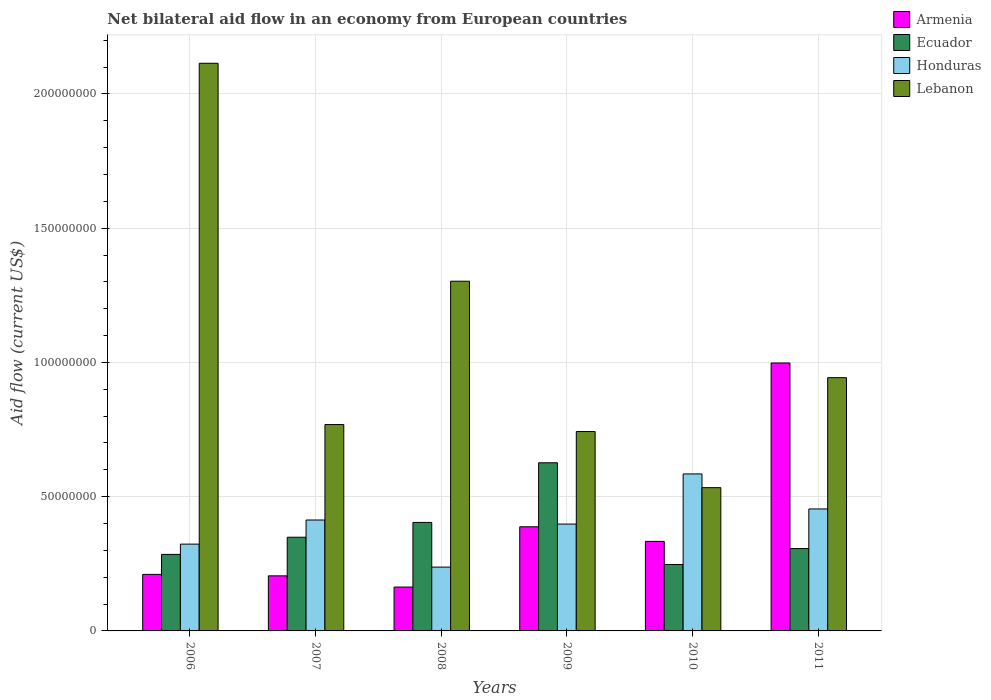How many different coloured bars are there?
Provide a succinct answer. 4. Are the number of bars on each tick of the X-axis equal?
Ensure brevity in your answer.  Yes. How many bars are there on the 2nd tick from the left?
Ensure brevity in your answer.  4. What is the net bilateral aid flow in Lebanon in 2011?
Provide a short and direct response. 9.43e+07. Across all years, what is the maximum net bilateral aid flow in Ecuador?
Keep it short and to the point. 6.26e+07. Across all years, what is the minimum net bilateral aid flow in Ecuador?
Your answer should be compact. 2.47e+07. In which year was the net bilateral aid flow in Armenia minimum?
Ensure brevity in your answer.  2008. What is the total net bilateral aid flow in Honduras in the graph?
Keep it short and to the point. 2.41e+08. What is the difference between the net bilateral aid flow in Honduras in 2008 and that in 2011?
Keep it short and to the point. -2.17e+07. What is the difference between the net bilateral aid flow in Armenia in 2007 and the net bilateral aid flow in Ecuador in 2009?
Ensure brevity in your answer.  -4.21e+07. What is the average net bilateral aid flow in Honduras per year?
Provide a short and direct response. 4.02e+07. In the year 2007, what is the difference between the net bilateral aid flow in Lebanon and net bilateral aid flow in Armenia?
Give a very brief answer. 5.64e+07. In how many years, is the net bilateral aid flow in Armenia greater than 90000000 US$?
Provide a short and direct response. 1. What is the ratio of the net bilateral aid flow in Ecuador in 2009 to that in 2011?
Keep it short and to the point. 2.04. Is the net bilateral aid flow in Honduras in 2010 less than that in 2011?
Your response must be concise. No. Is the difference between the net bilateral aid flow in Lebanon in 2006 and 2008 greater than the difference between the net bilateral aid flow in Armenia in 2006 and 2008?
Your answer should be very brief. Yes. What is the difference between the highest and the second highest net bilateral aid flow in Ecuador?
Give a very brief answer. 2.22e+07. What is the difference between the highest and the lowest net bilateral aid flow in Ecuador?
Offer a terse response. 3.79e+07. What does the 4th bar from the left in 2007 represents?
Keep it short and to the point. Lebanon. What does the 3rd bar from the right in 2006 represents?
Your response must be concise. Ecuador. Is it the case that in every year, the sum of the net bilateral aid flow in Lebanon and net bilateral aid flow in Armenia is greater than the net bilateral aid flow in Honduras?
Give a very brief answer. Yes. Are all the bars in the graph horizontal?
Provide a succinct answer. No. How many years are there in the graph?
Provide a short and direct response. 6. What is the difference between two consecutive major ticks on the Y-axis?
Offer a very short reply. 5.00e+07. Does the graph contain any zero values?
Offer a terse response. No. Does the graph contain grids?
Provide a short and direct response. Yes. Where does the legend appear in the graph?
Offer a very short reply. Top right. What is the title of the graph?
Keep it short and to the point. Net bilateral aid flow in an economy from European countries. What is the label or title of the X-axis?
Offer a very short reply. Years. What is the Aid flow (current US$) of Armenia in 2006?
Provide a succinct answer. 2.10e+07. What is the Aid flow (current US$) in Ecuador in 2006?
Ensure brevity in your answer.  2.85e+07. What is the Aid flow (current US$) of Honduras in 2006?
Offer a very short reply. 3.23e+07. What is the Aid flow (current US$) in Lebanon in 2006?
Ensure brevity in your answer.  2.11e+08. What is the Aid flow (current US$) of Armenia in 2007?
Your answer should be very brief. 2.05e+07. What is the Aid flow (current US$) in Ecuador in 2007?
Offer a very short reply. 3.49e+07. What is the Aid flow (current US$) in Honduras in 2007?
Provide a succinct answer. 4.13e+07. What is the Aid flow (current US$) in Lebanon in 2007?
Give a very brief answer. 7.69e+07. What is the Aid flow (current US$) of Armenia in 2008?
Your answer should be very brief. 1.63e+07. What is the Aid flow (current US$) in Ecuador in 2008?
Make the answer very short. 4.04e+07. What is the Aid flow (current US$) of Honduras in 2008?
Offer a very short reply. 2.38e+07. What is the Aid flow (current US$) of Lebanon in 2008?
Provide a short and direct response. 1.30e+08. What is the Aid flow (current US$) in Armenia in 2009?
Give a very brief answer. 3.88e+07. What is the Aid flow (current US$) in Ecuador in 2009?
Give a very brief answer. 6.26e+07. What is the Aid flow (current US$) of Honduras in 2009?
Give a very brief answer. 3.98e+07. What is the Aid flow (current US$) of Lebanon in 2009?
Your answer should be compact. 7.43e+07. What is the Aid flow (current US$) of Armenia in 2010?
Your response must be concise. 3.34e+07. What is the Aid flow (current US$) in Ecuador in 2010?
Keep it short and to the point. 2.47e+07. What is the Aid flow (current US$) of Honduras in 2010?
Give a very brief answer. 5.85e+07. What is the Aid flow (current US$) in Lebanon in 2010?
Give a very brief answer. 5.34e+07. What is the Aid flow (current US$) in Armenia in 2011?
Provide a succinct answer. 9.98e+07. What is the Aid flow (current US$) in Ecuador in 2011?
Keep it short and to the point. 3.07e+07. What is the Aid flow (current US$) in Honduras in 2011?
Your answer should be compact. 4.54e+07. What is the Aid flow (current US$) of Lebanon in 2011?
Keep it short and to the point. 9.43e+07. Across all years, what is the maximum Aid flow (current US$) of Armenia?
Provide a short and direct response. 9.98e+07. Across all years, what is the maximum Aid flow (current US$) in Ecuador?
Your answer should be very brief. 6.26e+07. Across all years, what is the maximum Aid flow (current US$) in Honduras?
Provide a succinct answer. 5.85e+07. Across all years, what is the maximum Aid flow (current US$) in Lebanon?
Your answer should be compact. 2.11e+08. Across all years, what is the minimum Aid flow (current US$) of Armenia?
Your answer should be very brief. 1.63e+07. Across all years, what is the minimum Aid flow (current US$) in Ecuador?
Offer a terse response. 2.47e+07. Across all years, what is the minimum Aid flow (current US$) in Honduras?
Provide a succinct answer. 2.38e+07. Across all years, what is the minimum Aid flow (current US$) of Lebanon?
Your answer should be very brief. 5.34e+07. What is the total Aid flow (current US$) of Armenia in the graph?
Keep it short and to the point. 2.30e+08. What is the total Aid flow (current US$) in Ecuador in the graph?
Your response must be concise. 2.22e+08. What is the total Aid flow (current US$) in Honduras in the graph?
Give a very brief answer. 2.41e+08. What is the total Aid flow (current US$) in Lebanon in the graph?
Ensure brevity in your answer.  6.40e+08. What is the difference between the Aid flow (current US$) of Armenia in 2006 and that in 2007?
Your answer should be very brief. 5.40e+05. What is the difference between the Aid flow (current US$) of Ecuador in 2006 and that in 2007?
Keep it short and to the point. -6.40e+06. What is the difference between the Aid flow (current US$) of Honduras in 2006 and that in 2007?
Offer a terse response. -8.98e+06. What is the difference between the Aid flow (current US$) in Lebanon in 2006 and that in 2007?
Offer a very short reply. 1.35e+08. What is the difference between the Aid flow (current US$) in Armenia in 2006 and that in 2008?
Ensure brevity in your answer.  4.71e+06. What is the difference between the Aid flow (current US$) of Ecuador in 2006 and that in 2008?
Ensure brevity in your answer.  -1.19e+07. What is the difference between the Aid flow (current US$) of Honduras in 2006 and that in 2008?
Your answer should be very brief. 8.56e+06. What is the difference between the Aid flow (current US$) of Lebanon in 2006 and that in 2008?
Your answer should be very brief. 8.12e+07. What is the difference between the Aid flow (current US$) in Armenia in 2006 and that in 2009?
Your response must be concise. -1.77e+07. What is the difference between the Aid flow (current US$) in Ecuador in 2006 and that in 2009?
Make the answer very short. -3.41e+07. What is the difference between the Aid flow (current US$) in Honduras in 2006 and that in 2009?
Your answer should be very brief. -7.47e+06. What is the difference between the Aid flow (current US$) of Lebanon in 2006 and that in 2009?
Your answer should be very brief. 1.37e+08. What is the difference between the Aid flow (current US$) of Armenia in 2006 and that in 2010?
Your answer should be compact. -1.23e+07. What is the difference between the Aid flow (current US$) of Ecuador in 2006 and that in 2010?
Provide a short and direct response. 3.76e+06. What is the difference between the Aid flow (current US$) in Honduras in 2006 and that in 2010?
Your answer should be very brief. -2.61e+07. What is the difference between the Aid flow (current US$) of Lebanon in 2006 and that in 2010?
Give a very brief answer. 1.58e+08. What is the difference between the Aid flow (current US$) in Armenia in 2006 and that in 2011?
Keep it short and to the point. -7.87e+07. What is the difference between the Aid flow (current US$) in Ecuador in 2006 and that in 2011?
Give a very brief answer. -2.18e+06. What is the difference between the Aid flow (current US$) in Honduras in 2006 and that in 2011?
Give a very brief answer. -1.31e+07. What is the difference between the Aid flow (current US$) of Lebanon in 2006 and that in 2011?
Give a very brief answer. 1.17e+08. What is the difference between the Aid flow (current US$) of Armenia in 2007 and that in 2008?
Offer a very short reply. 4.17e+06. What is the difference between the Aid flow (current US$) in Ecuador in 2007 and that in 2008?
Your answer should be compact. -5.51e+06. What is the difference between the Aid flow (current US$) of Honduras in 2007 and that in 2008?
Keep it short and to the point. 1.75e+07. What is the difference between the Aid flow (current US$) of Lebanon in 2007 and that in 2008?
Make the answer very short. -5.34e+07. What is the difference between the Aid flow (current US$) of Armenia in 2007 and that in 2009?
Provide a succinct answer. -1.83e+07. What is the difference between the Aid flow (current US$) of Ecuador in 2007 and that in 2009?
Make the answer very short. -2.77e+07. What is the difference between the Aid flow (current US$) in Honduras in 2007 and that in 2009?
Provide a short and direct response. 1.51e+06. What is the difference between the Aid flow (current US$) of Lebanon in 2007 and that in 2009?
Offer a very short reply. 2.60e+06. What is the difference between the Aid flow (current US$) of Armenia in 2007 and that in 2010?
Keep it short and to the point. -1.28e+07. What is the difference between the Aid flow (current US$) in Ecuador in 2007 and that in 2010?
Give a very brief answer. 1.02e+07. What is the difference between the Aid flow (current US$) of Honduras in 2007 and that in 2010?
Your answer should be compact. -1.72e+07. What is the difference between the Aid flow (current US$) in Lebanon in 2007 and that in 2010?
Offer a very short reply. 2.35e+07. What is the difference between the Aid flow (current US$) in Armenia in 2007 and that in 2011?
Make the answer very short. -7.93e+07. What is the difference between the Aid flow (current US$) of Ecuador in 2007 and that in 2011?
Your response must be concise. 4.22e+06. What is the difference between the Aid flow (current US$) in Honduras in 2007 and that in 2011?
Make the answer very short. -4.12e+06. What is the difference between the Aid flow (current US$) of Lebanon in 2007 and that in 2011?
Keep it short and to the point. -1.75e+07. What is the difference between the Aid flow (current US$) in Armenia in 2008 and that in 2009?
Your answer should be very brief. -2.24e+07. What is the difference between the Aid flow (current US$) in Ecuador in 2008 and that in 2009?
Make the answer very short. -2.22e+07. What is the difference between the Aid flow (current US$) in Honduras in 2008 and that in 2009?
Keep it short and to the point. -1.60e+07. What is the difference between the Aid flow (current US$) of Lebanon in 2008 and that in 2009?
Give a very brief answer. 5.60e+07. What is the difference between the Aid flow (current US$) of Armenia in 2008 and that in 2010?
Make the answer very short. -1.70e+07. What is the difference between the Aid flow (current US$) in Ecuador in 2008 and that in 2010?
Give a very brief answer. 1.57e+07. What is the difference between the Aid flow (current US$) of Honduras in 2008 and that in 2010?
Give a very brief answer. -3.47e+07. What is the difference between the Aid flow (current US$) of Lebanon in 2008 and that in 2010?
Your response must be concise. 7.69e+07. What is the difference between the Aid flow (current US$) in Armenia in 2008 and that in 2011?
Offer a very short reply. -8.34e+07. What is the difference between the Aid flow (current US$) in Ecuador in 2008 and that in 2011?
Your answer should be compact. 9.73e+06. What is the difference between the Aid flow (current US$) of Honduras in 2008 and that in 2011?
Your response must be concise. -2.17e+07. What is the difference between the Aid flow (current US$) in Lebanon in 2008 and that in 2011?
Make the answer very short. 3.59e+07. What is the difference between the Aid flow (current US$) in Armenia in 2009 and that in 2010?
Keep it short and to the point. 5.44e+06. What is the difference between the Aid flow (current US$) of Ecuador in 2009 and that in 2010?
Offer a terse response. 3.79e+07. What is the difference between the Aid flow (current US$) of Honduras in 2009 and that in 2010?
Provide a succinct answer. -1.87e+07. What is the difference between the Aid flow (current US$) in Lebanon in 2009 and that in 2010?
Offer a terse response. 2.09e+07. What is the difference between the Aid flow (current US$) of Armenia in 2009 and that in 2011?
Your response must be concise. -6.10e+07. What is the difference between the Aid flow (current US$) in Ecuador in 2009 and that in 2011?
Offer a very short reply. 3.20e+07. What is the difference between the Aid flow (current US$) in Honduras in 2009 and that in 2011?
Your answer should be compact. -5.63e+06. What is the difference between the Aid flow (current US$) of Lebanon in 2009 and that in 2011?
Give a very brief answer. -2.01e+07. What is the difference between the Aid flow (current US$) of Armenia in 2010 and that in 2011?
Your answer should be compact. -6.64e+07. What is the difference between the Aid flow (current US$) of Ecuador in 2010 and that in 2011?
Make the answer very short. -5.94e+06. What is the difference between the Aid flow (current US$) of Honduras in 2010 and that in 2011?
Keep it short and to the point. 1.30e+07. What is the difference between the Aid flow (current US$) in Lebanon in 2010 and that in 2011?
Ensure brevity in your answer.  -4.10e+07. What is the difference between the Aid flow (current US$) in Armenia in 2006 and the Aid flow (current US$) in Ecuador in 2007?
Make the answer very short. -1.38e+07. What is the difference between the Aid flow (current US$) in Armenia in 2006 and the Aid flow (current US$) in Honduras in 2007?
Your answer should be very brief. -2.03e+07. What is the difference between the Aid flow (current US$) in Armenia in 2006 and the Aid flow (current US$) in Lebanon in 2007?
Make the answer very short. -5.58e+07. What is the difference between the Aid flow (current US$) in Ecuador in 2006 and the Aid flow (current US$) in Honduras in 2007?
Make the answer very short. -1.28e+07. What is the difference between the Aid flow (current US$) in Ecuador in 2006 and the Aid flow (current US$) in Lebanon in 2007?
Keep it short and to the point. -4.84e+07. What is the difference between the Aid flow (current US$) of Honduras in 2006 and the Aid flow (current US$) of Lebanon in 2007?
Ensure brevity in your answer.  -4.45e+07. What is the difference between the Aid flow (current US$) in Armenia in 2006 and the Aid flow (current US$) in Ecuador in 2008?
Your answer should be compact. -1.94e+07. What is the difference between the Aid flow (current US$) in Armenia in 2006 and the Aid flow (current US$) in Honduras in 2008?
Your answer should be compact. -2.72e+06. What is the difference between the Aid flow (current US$) of Armenia in 2006 and the Aid flow (current US$) of Lebanon in 2008?
Your answer should be compact. -1.09e+08. What is the difference between the Aid flow (current US$) in Ecuador in 2006 and the Aid flow (current US$) in Honduras in 2008?
Give a very brief answer. 4.73e+06. What is the difference between the Aid flow (current US$) of Ecuador in 2006 and the Aid flow (current US$) of Lebanon in 2008?
Offer a terse response. -1.02e+08. What is the difference between the Aid flow (current US$) in Honduras in 2006 and the Aid flow (current US$) in Lebanon in 2008?
Your answer should be compact. -9.79e+07. What is the difference between the Aid flow (current US$) in Armenia in 2006 and the Aid flow (current US$) in Ecuador in 2009?
Your answer should be very brief. -4.16e+07. What is the difference between the Aid flow (current US$) in Armenia in 2006 and the Aid flow (current US$) in Honduras in 2009?
Ensure brevity in your answer.  -1.88e+07. What is the difference between the Aid flow (current US$) of Armenia in 2006 and the Aid flow (current US$) of Lebanon in 2009?
Your answer should be compact. -5.32e+07. What is the difference between the Aid flow (current US$) in Ecuador in 2006 and the Aid flow (current US$) in Honduras in 2009?
Provide a short and direct response. -1.13e+07. What is the difference between the Aid flow (current US$) in Ecuador in 2006 and the Aid flow (current US$) in Lebanon in 2009?
Offer a terse response. -4.58e+07. What is the difference between the Aid flow (current US$) of Honduras in 2006 and the Aid flow (current US$) of Lebanon in 2009?
Provide a succinct answer. -4.19e+07. What is the difference between the Aid flow (current US$) in Armenia in 2006 and the Aid flow (current US$) in Ecuador in 2010?
Keep it short and to the point. -3.69e+06. What is the difference between the Aid flow (current US$) of Armenia in 2006 and the Aid flow (current US$) of Honduras in 2010?
Offer a terse response. -3.74e+07. What is the difference between the Aid flow (current US$) in Armenia in 2006 and the Aid flow (current US$) in Lebanon in 2010?
Your answer should be compact. -3.23e+07. What is the difference between the Aid flow (current US$) of Ecuador in 2006 and the Aid flow (current US$) of Honduras in 2010?
Your answer should be compact. -3.00e+07. What is the difference between the Aid flow (current US$) in Ecuador in 2006 and the Aid flow (current US$) in Lebanon in 2010?
Ensure brevity in your answer.  -2.49e+07. What is the difference between the Aid flow (current US$) in Honduras in 2006 and the Aid flow (current US$) in Lebanon in 2010?
Offer a terse response. -2.10e+07. What is the difference between the Aid flow (current US$) of Armenia in 2006 and the Aid flow (current US$) of Ecuador in 2011?
Your response must be concise. -9.63e+06. What is the difference between the Aid flow (current US$) of Armenia in 2006 and the Aid flow (current US$) of Honduras in 2011?
Your answer should be very brief. -2.44e+07. What is the difference between the Aid flow (current US$) in Armenia in 2006 and the Aid flow (current US$) in Lebanon in 2011?
Keep it short and to the point. -7.33e+07. What is the difference between the Aid flow (current US$) in Ecuador in 2006 and the Aid flow (current US$) in Honduras in 2011?
Provide a succinct answer. -1.69e+07. What is the difference between the Aid flow (current US$) in Ecuador in 2006 and the Aid flow (current US$) in Lebanon in 2011?
Provide a succinct answer. -6.58e+07. What is the difference between the Aid flow (current US$) of Honduras in 2006 and the Aid flow (current US$) of Lebanon in 2011?
Provide a short and direct response. -6.20e+07. What is the difference between the Aid flow (current US$) in Armenia in 2007 and the Aid flow (current US$) in Ecuador in 2008?
Offer a terse response. -1.99e+07. What is the difference between the Aid flow (current US$) of Armenia in 2007 and the Aid flow (current US$) of Honduras in 2008?
Give a very brief answer. -3.26e+06. What is the difference between the Aid flow (current US$) of Armenia in 2007 and the Aid flow (current US$) of Lebanon in 2008?
Provide a succinct answer. -1.10e+08. What is the difference between the Aid flow (current US$) in Ecuador in 2007 and the Aid flow (current US$) in Honduras in 2008?
Ensure brevity in your answer.  1.11e+07. What is the difference between the Aid flow (current US$) in Ecuador in 2007 and the Aid flow (current US$) in Lebanon in 2008?
Provide a short and direct response. -9.54e+07. What is the difference between the Aid flow (current US$) of Honduras in 2007 and the Aid flow (current US$) of Lebanon in 2008?
Offer a terse response. -8.89e+07. What is the difference between the Aid flow (current US$) of Armenia in 2007 and the Aid flow (current US$) of Ecuador in 2009?
Make the answer very short. -4.21e+07. What is the difference between the Aid flow (current US$) of Armenia in 2007 and the Aid flow (current US$) of Honduras in 2009?
Your response must be concise. -1.93e+07. What is the difference between the Aid flow (current US$) of Armenia in 2007 and the Aid flow (current US$) of Lebanon in 2009?
Ensure brevity in your answer.  -5.38e+07. What is the difference between the Aid flow (current US$) in Ecuador in 2007 and the Aid flow (current US$) in Honduras in 2009?
Provide a short and direct response. -4.90e+06. What is the difference between the Aid flow (current US$) in Ecuador in 2007 and the Aid flow (current US$) in Lebanon in 2009?
Ensure brevity in your answer.  -3.94e+07. What is the difference between the Aid flow (current US$) of Honduras in 2007 and the Aid flow (current US$) of Lebanon in 2009?
Give a very brief answer. -3.30e+07. What is the difference between the Aid flow (current US$) in Armenia in 2007 and the Aid flow (current US$) in Ecuador in 2010?
Offer a very short reply. -4.23e+06. What is the difference between the Aid flow (current US$) of Armenia in 2007 and the Aid flow (current US$) of Honduras in 2010?
Your answer should be compact. -3.80e+07. What is the difference between the Aid flow (current US$) in Armenia in 2007 and the Aid flow (current US$) in Lebanon in 2010?
Your answer should be compact. -3.28e+07. What is the difference between the Aid flow (current US$) of Ecuador in 2007 and the Aid flow (current US$) of Honduras in 2010?
Provide a short and direct response. -2.36e+07. What is the difference between the Aid flow (current US$) of Ecuador in 2007 and the Aid flow (current US$) of Lebanon in 2010?
Offer a terse response. -1.85e+07. What is the difference between the Aid flow (current US$) of Honduras in 2007 and the Aid flow (current US$) of Lebanon in 2010?
Offer a very short reply. -1.20e+07. What is the difference between the Aid flow (current US$) of Armenia in 2007 and the Aid flow (current US$) of Ecuador in 2011?
Offer a very short reply. -1.02e+07. What is the difference between the Aid flow (current US$) in Armenia in 2007 and the Aid flow (current US$) in Honduras in 2011?
Your response must be concise. -2.49e+07. What is the difference between the Aid flow (current US$) of Armenia in 2007 and the Aid flow (current US$) of Lebanon in 2011?
Your response must be concise. -7.38e+07. What is the difference between the Aid flow (current US$) of Ecuador in 2007 and the Aid flow (current US$) of Honduras in 2011?
Offer a very short reply. -1.05e+07. What is the difference between the Aid flow (current US$) in Ecuador in 2007 and the Aid flow (current US$) in Lebanon in 2011?
Your response must be concise. -5.94e+07. What is the difference between the Aid flow (current US$) in Honduras in 2007 and the Aid flow (current US$) in Lebanon in 2011?
Make the answer very short. -5.30e+07. What is the difference between the Aid flow (current US$) in Armenia in 2008 and the Aid flow (current US$) in Ecuador in 2009?
Make the answer very short. -4.63e+07. What is the difference between the Aid flow (current US$) of Armenia in 2008 and the Aid flow (current US$) of Honduras in 2009?
Your answer should be compact. -2.35e+07. What is the difference between the Aid flow (current US$) of Armenia in 2008 and the Aid flow (current US$) of Lebanon in 2009?
Your answer should be compact. -5.79e+07. What is the difference between the Aid flow (current US$) of Ecuador in 2008 and the Aid flow (current US$) of Honduras in 2009?
Offer a very short reply. 6.10e+05. What is the difference between the Aid flow (current US$) of Ecuador in 2008 and the Aid flow (current US$) of Lebanon in 2009?
Offer a terse response. -3.38e+07. What is the difference between the Aid flow (current US$) in Honduras in 2008 and the Aid flow (current US$) in Lebanon in 2009?
Your answer should be compact. -5.05e+07. What is the difference between the Aid flow (current US$) in Armenia in 2008 and the Aid flow (current US$) in Ecuador in 2010?
Provide a succinct answer. -8.40e+06. What is the difference between the Aid flow (current US$) of Armenia in 2008 and the Aid flow (current US$) of Honduras in 2010?
Your answer should be compact. -4.21e+07. What is the difference between the Aid flow (current US$) of Armenia in 2008 and the Aid flow (current US$) of Lebanon in 2010?
Your answer should be very brief. -3.70e+07. What is the difference between the Aid flow (current US$) in Ecuador in 2008 and the Aid flow (current US$) in Honduras in 2010?
Your answer should be very brief. -1.81e+07. What is the difference between the Aid flow (current US$) of Ecuador in 2008 and the Aid flow (current US$) of Lebanon in 2010?
Keep it short and to the point. -1.30e+07. What is the difference between the Aid flow (current US$) in Honduras in 2008 and the Aid flow (current US$) in Lebanon in 2010?
Give a very brief answer. -2.96e+07. What is the difference between the Aid flow (current US$) in Armenia in 2008 and the Aid flow (current US$) in Ecuador in 2011?
Make the answer very short. -1.43e+07. What is the difference between the Aid flow (current US$) of Armenia in 2008 and the Aid flow (current US$) of Honduras in 2011?
Give a very brief answer. -2.91e+07. What is the difference between the Aid flow (current US$) of Armenia in 2008 and the Aid flow (current US$) of Lebanon in 2011?
Your answer should be very brief. -7.80e+07. What is the difference between the Aid flow (current US$) of Ecuador in 2008 and the Aid flow (current US$) of Honduras in 2011?
Keep it short and to the point. -5.02e+06. What is the difference between the Aid flow (current US$) of Ecuador in 2008 and the Aid flow (current US$) of Lebanon in 2011?
Give a very brief answer. -5.39e+07. What is the difference between the Aid flow (current US$) in Honduras in 2008 and the Aid flow (current US$) in Lebanon in 2011?
Provide a short and direct response. -7.06e+07. What is the difference between the Aid flow (current US$) of Armenia in 2009 and the Aid flow (current US$) of Ecuador in 2010?
Offer a terse response. 1.40e+07. What is the difference between the Aid flow (current US$) of Armenia in 2009 and the Aid flow (current US$) of Honduras in 2010?
Your response must be concise. -1.97e+07. What is the difference between the Aid flow (current US$) of Armenia in 2009 and the Aid flow (current US$) of Lebanon in 2010?
Your answer should be compact. -1.46e+07. What is the difference between the Aid flow (current US$) of Ecuador in 2009 and the Aid flow (current US$) of Honduras in 2010?
Your answer should be very brief. 4.16e+06. What is the difference between the Aid flow (current US$) in Ecuador in 2009 and the Aid flow (current US$) in Lebanon in 2010?
Your answer should be very brief. 9.27e+06. What is the difference between the Aid flow (current US$) of Honduras in 2009 and the Aid flow (current US$) of Lebanon in 2010?
Your answer should be very brief. -1.36e+07. What is the difference between the Aid flow (current US$) in Armenia in 2009 and the Aid flow (current US$) in Ecuador in 2011?
Keep it short and to the point. 8.11e+06. What is the difference between the Aid flow (current US$) in Armenia in 2009 and the Aid flow (current US$) in Honduras in 2011?
Your response must be concise. -6.64e+06. What is the difference between the Aid flow (current US$) of Armenia in 2009 and the Aid flow (current US$) of Lebanon in 2011?
Provide a short and direct response. -5.55e+07. What is the difference between the Aid flow (current US$) of Ecuador in 2009 and the Aid flow (current US$) of Honduras in 2011?
Your answer should be very brief. 1.72e+07. What is the difference between the Aid flow (current US$) of Ecuador in 2009 and the Aid flow (current US$) of Lebanon in 2011?
Give a very brief answer. -3.17e+07. What is the difference between the Aid flow (current US$) in Honduras in 2009 and the Aid flow (current US$) in Lebanon in 2011?
Your answer should be very brief. -5.45e+07. What is the difference between the Aid flow (current US$) in Armenia in 2010 and the Aid flow (current US$) in Ecuador in 2011?
Your answer should be very brief. 2.67e+06. What is the difference between the Aid flow (current US$) in Armenia in 2010 and the Aid flow (current US$) in Honduras in 2011?
Offer a terse response. -1.21e+07. What is the difference between the Aid flow (current US$) of Armenia in 2010 and the Aid flow (current US$) of Lebanon in 2011?
Provide a short and direct response. -6.10e+07. What is the difference between the Aid flow (current US$) in Ecuador in 2010 and the Aid flow (current US$) in Honduras in 2011?
Your response must be concise. -2.07e+07. What is the difference between the Aid flow (current US$) in Ecuador in 2010 and the Aid flow (current US$) in Lebanon in 2011?
Offer a very short reply. -6.96e+07. What is the difference between the Aid flow (current US$) of Honduras in 2010 and the Aid flow (current US$) of Lebanon in 2011?
Provide a succinct answer. -3.59e+07. What is the average Aid flow (current US$) of Armenia per year?
Keep it short and to the point. 3.83e+07. What is the average Aid flow (current US$) in Ecuador per year?
Provide a short and direct response. 3.70e+07. What is the average Aid flow (current US$) in Honduras per year?
Ensure brevity in your answer.  4.02e+07. What is the average Aid flow (current US$) of Lebanon per year?
Provide a short and direct response. 1.07e+08. In the year 2006, what is the difference between the Aid flow (current US$) in Armenia and Aid flow (current US$) in Ecuador?
Your answer should be very brief. -7.45e+06. In the year 2006, what is the difference between the Aid flow (current US$) in Armenia and Aid flow (current US$) in Honduras?
Keep it short and to the point. -1.13e+07. In the year 2006, what is the difference between the Aid flow (current US$) of Armenia and Aid flow (current US$) of Lebanon?
Your response must be concise. -1.90e+08. In the year 2006, what is the difference between the Aid flow (current US$) of Ecuador and Aid flow (current US$) of Honduras?
Your response must be concise. -3.83e+06. In the year 2006, what is the difference between the Aid flow (current US$) in Ecuador and Aid flow (current US$) in Lebanon?
Your answer should be compact. -1.83e+08. In the year 2006, what is the difference between the Aid flow (current US$) in Honduras and Aid flow (current US$) in Lebanon?
Your answer should be compact. -1.79e+08. In the year 2007, what is the difference between the Aid flow (current US$) of Armenia and Aid flow (current US$) of Ecuador?
Your response must be concise. -1.44e+07. In the year 2007, what is the difference between the Aid flow (current US$) of Armenia and Aid flow (current US$) of Honduras?
Offer a terse response. -2.08e+07. In the year 2007, what is the difference between the Aid flow (current US$) in Armenia and Aid flow (current US$) in Lebanon?
Your answer should be very brief. -5.64e+07. In the year 2007, what is the difference between the Aid flow (current US$) in Ecuador and Aid flow (current US$) in Honduras?
Ensure brevity in your answer.  -6.41e+06. In the year 2007, what is the difference between the Aid flow (current US$) in Ecuador and Aid flow (current US$) in Lebanon?
Offer a terse response. -4.20e+07. In the year 2007, what is the difference between the Aid flow (current US$) of Honduras and Aid flow (current US$) of Lebanon?
Give a very brief answer. -3.56e+07. In the year 2008, what is the difference between the Aid flow (current US$) in Armenia and Aid flow (current US$) in Ecuador?
Make the answer very short. -2.41e+07. In the year 2008, what is the difference between the Aid flow (current US$) in Armenia and Aid flow (current US$) in Honduras?
Your answer should be compact. -7.43e+06. In the year 2008, what is the difference between the Aid flow (current US$) of Armenia and Aid flow (current US$) of Lebanon?
Your response must be concise. -1.14e+08. In the year 2008, what is the difference between the Aid flow (current US$) in Ecuador and Aid flow (current US$) in Honduras?
Your answer should be compact. 1.66e+07. In the year 2008, what is the difference between the Aid flow (current US$) in Ecuador and Aid flow (current US$) in Lebanon?
Give a very brief answer. -8.98e+07. In the year 2008, what is the difference between the Aid flow (current US$) of Honduras and Aid flow (current US$) of Lebanon?
Make the answer very short. -1.06e+08. In the year 2009, what is the difference between the Aid flow (current US$) of Armenia and Aid flow (current US$) of Ecuador?
Provide a succinct answer. -2.38e+07. In the year 2009, what is the difference between the Aid flow (current US$) of Armenia and Aid flow (current US$) of Honduras?
Your answer should be very brief. -1.01e+06. In the year 2009, what is the difference between the Aid flow (current US$) in Armenia and Aid flow (current US$) in Lebanon?
Give a very brief answer. -3.55e+07. In the year 2009, what is the difference between the Aid flow (current US$) of Ecuador and Aid flow (current US$) of Honduras?
Offer a terse response. 2.28e+07. In the year 2009, what is the difference between the Aid flow (current US$) in Ecuador and Aid flow (current US$) in Lebanon?
Give a very brief answer. -1.16e+07. In the year 2009, what is the difference between the Aid flow (current US$) in Honduras and Aid flow (current US$) in Lebanon?
Your answer should be compact. -3.45e+07. In the year 2010, what is the difference between the Aid flow (current US$) of Armenia and Aid flow (current US$) of Ecuador?
Your response must be concise. 8.61e+06. In the year 2010, what is the difference between the Aid flow (current US$) in Armenia and Aid flow (current US$) in Honduras?
Your answer should be compact. -2.51e+07. In the year 2010, what is the difference between the Aid flow (current US$) in Armenia and Aid flow (current US$) in Lebanon?
Provide a short and direct response. -2.00e+07. In the year 2010, what is the difference between the Aid flow (current US$) in Ecuador and Aid flow (current US$) in Honduras?
Provide a succinct answer. -3.37e+07. In the year 2010, what is the difference between the Aid flow (current US$) of Ecuador and Aid flow (current US$) of Lebanon?
Make the answer very short. -2.86e+07. In the year 2010, what is the difference between the Aid flow (current US$) of Honduras and Aid flow (current US$) of Lebanon?
Make the answer very short. 5.11e+06. In the year 2011, what is the difference between the Aid flow (current US$) in Armenia and Aid flow (current US$) in Ecuador?
Provide a succinct answer. 6.91e+07. In the year 2011, what is the difference between the Aid flow (current US$) in Armenia and Aid flow (current US$) in Honduras?
Ensure brevity in your answer.  5.44e+07. In the year 2011, what is the difference between the Aid flow (current US$) of Armenia and Aid flow (current US$) of Lebanon?
Your answer should be compact. 5.46e+06. In the year 2011, what is the difference between the Aid flow (current US$) of Ecuador and Aid flow (current US$) of Honduras?
Provide a succinct answer. -1.48e+07. In the year 2011, what is the difference between the Aid flow (current US$) in Ecuador and Aid flow (current US$) in Lebanon?
Make the answer very short. -6.36e+07. In the year 2011, what is the difference between the Aid flow (current US$) in Honduras and Aid flow (current US$) in Lebanon?
Provide a succinct answer. -4.89e+07. What is the ratio of the Aid flow (current US$) of Armenia in 2006 to that in 2007?
Offer a very short reply. 1.03. What is the ratio of the Aid flow (current US$) in Ecuador in 2006 to that in 2007?
Make the answer very short. 0.82. What is the ratio of the Aid flow (current US$) in Honduras in 2006 to that in 2007?
Your answer should be very brief. 0.78. What is the ratio of the Aid flow (current US$) of Lebanon in 2006 to that in 2007?
Offer a very short reply. 2.75. What is the ratio of the Aid flow (current US$) of Armenia in 2006 to that in 2008?
Make the answer very short. 1.29. What is the ratio of the Aid flow (current US$) of Ecuador in 2006 to that in 2008?
Keep it short and to the point. 0.71. What is the ratio of the Aid flow (current US$) in Honduras in 2006 to that in 2008?
Keep it short and to the point. 1.36. What is the ratio of the Aid flow (current US$) of Lebanon in 2006 to that in 2008?
Ensure brevity in your answer.  1.62. What is the ratio of the Aid flow (current US$) of Armenia in 2006 to that in 2009?
Give a very brief answer. 0.54. What is the ratio of the Aid flow (current US$) in Ecuador in 2006 to that in 2009?
Make the answer very short. 0.46. What is the ratio of the Aid flow (current US$) of Honduras in 2006 to that in 2009?
Offer a terse response. 0.81. What is the ratio of the Aid flow (current US$) in Lebanon in 2006 to that in 2009?
Provide a short and direct response. 2.85. What is the ratio of the Aid flow (current US$) in Armenia in 2006 to that in 2010?
Keep it short and to the point. 0.63. What is the ratio of the Aid flow (current US$) of Ecuador in 2006 to that in 2010?
Your response must be concise. 1.15. What is the ratio of the Aid flow (current US$) of Honduras in 2006 to that in 2010?
Offer a very short reply. 0.55. What is the ratio of the Aid flow (current US$) of Lebanon in 2006 to that in 2010?
Your response must be concise. 3.96. What is the ratio of the Aid flow (current US$) in Armenia in 2006 to that in 2011?
Your answer should be very brief. 0.21. What is the ratio of the Aid flow (current US$) of Ecuador in 2006 to that in 2011?
Your answer should be compact. 0.93. What is the ratio of the Aid flow (current US$) of Honduras in 2006 to that in 2011?
Provide a short and direct response. 0.71. What is the ratio of the Aid flow (current US$) in Lebanon in 2006 to that in 2011?
Provide a short and direct response. 2.24. What is the ratio of the Aid flow (current US$) of Armenia in 2007 to that in 2008?
Offer a terse response. 1.26. What is the ratio of the Aid flow (current US$) of Ecuador in 2007 to that in 2008?
Offer a very short reply. 0.86. What is the ratio of the Aid flow (current US$) of Honduras in 2007 to that in 2008?
Keep it short and to the point. 1.74. What is the ratio of the Aid flow (current US$) in Lebanon in 2007 to that in 2008?
Your answer should be very brief. 0.59. What is the ratio of the Aid flow (current US$) of Armenia in 2007 to that in 2009?
Your answer should be very brief. 0.53. What is the ratio of the Aid flow (current US$) of Ecuador in 2007 to that in 2009?
Your answer should be compact. 0.56. What is the ratio of the Aid flow (current US$) of Honduras in 2007 to that in 2009?
Give a very brief answer. 1.04. What is the ratio of the Aid flow (current US$) in Lebanon in 2007 to that in 2009?
Offer a terse response. 1.03. What is the ratio of the Aid flow (current US$) in Armenia in 2007 to that in 2010?
Offer a terse response. 0.61. What is the ratio of the Aid flow (current US$) in Ecuador in 2007 to that in 2010?
Offer a terse response. 1.41. What is the ratio of the Aid flow (current US$) in Honduras in 2007 to that in 2010?
Make the answer very short. 0.71. What is the ratio of the Aid flow (current US$) of Lebanon in 2007 to that in 2010?
Give a very brief answer. 1.44. What is the ratio of the Aid flow (current US$) in Armenia in 2007 to that in 2011?
Your answer should be compact. 0.21. What is the ratio of the Aid flow (current US$) of Ecuador in 2007 to that in 2011?
Your answer should be very brief. 1.14. What is the ratio of the Aid flow (current US$) in Honduras in 2007 to that in 2011?
Your answer should be very brief. 0.91. What is the ratio of the Aid flow (current US$) of Lebanon in 2007 to that in 2011?
Offer a very short reply. 0.81. What is the ratio of the Aid flow (current US$) of Armenia in 2008 to that in 2009?
Give a very brief answer. 0.42. What is the ratio of the Aid flow (current US$) in Ecuador in 2008 to that in 2009?
Ensure brevity in your answer.  0.65. What is the ratio of the Aid flow (current US$) in Honduras in 2008 to that in 2009?
Ensure brevity in your answer.  0.6. What is the ratio of the Aid flow (current US$) in Lebanon in 2008 to that in 2009?
Provide a succinct answer. 1.75. What is the ratio of the Aid flow (current US$) of Armenia in 2008 to that in 2010?
Offer a terse response. 0.49. What is the ratio of the Aid flow (current US$) in Ecuador in 2008 to that in 2010?
Provide a short and direct response. 1.63. What is the ratio of the Aid flow (current US$) of Honduras in 2008 to that in 2010?
Your answer should be compact. 0.41. What is the ratio of the Aid flow (current US$) in Lebanon in 2008 to that in 2010?
Your answer should be very brief. 2.44. What is the ratio of the Aid flow (current US$) of Armenia in 2008 to that in 2011?
Your answer should be very brief. 0.16. What is the ratio of the Aid flow (current US$) of Ecuador in 2008 to that in 2011?
Provide a short and direct response. 1.32. What is the ratio of the Aid flow (current US$) of Honduras in 2008 to that in 2011?
Your answer should be very brief. 0.52. What is the ratio of the Aid flow (current US$) of Lebanon in 2008 to that in 2011?
Make the answer very short. 1.38. What is the ratio of the Aid flow (current US$) of Armenia in 2009 to that in 2010?
Offer a terse response. 1.16. What is the ratio of the Aid flow (current US$) in Ecuador in 2009 to that in 2010?
Provide a short and direct response. 2.53. What is the ratio of the Aid flow (current US$) in Honduras in 2009 to that in 2010?
Your response must be concise. 0.68. What is the ratio of the Aid flow (current US$) of Lebanon in 2009 to that in 2010?
Give a very brief answer. 1.39. What is the ratio of the Aid flow (current US$) of Armenia in 2009 to that in 2011?
Offer a very short reply. 0.39. What is the ratio of the Aid flow (current US$) in Ecuador in 2009 to that in 2011?
Provide a short and direct response. 2.04. What is the ratio of the Aid flow (current US$) of Honduras in 2009 to that in 2011?
Provide a succinct answer. 0.88. What is the ratio of the Aid flow (current US$) in Lebanon in 2009 to that in 2011?
Give a very brief answer. 0.79. What is the ratio of the Aid flow (current US$) in Armenia in 2010 to that in 2011?
Your response must be concise. 0.33. What is the ratio of the Aid flow (current US$) of Ecuador in 2010 to that in 2011?
Offer a terse response. 0.81. What is the ratio of the Aid flow (current US$) in Honduras in 2010 to that in 2011?
Provide a succinct answer. 1.29. What is the ratio of the Aid flow (current US$) of Lebanon in 2010 to that in 2011?
Give a very brief answer. 0.57. What is the difference between the highest and the second highest Aid flow (current US$) of Armenia?
Your answer should be very brief. 6.10e+07. What is the difference between the highest and the second highest Aid flow (current US$) of Ecuador?
Offer a terse response. 2.22e+07. What is the difference between the highest and the second highest Aid flow (current US$) in Honduras?
Keep it short and to the point. 1.30e+07. What is the difference between the highest and the second highest Aid flow (current US$) of Lebanon?
Provide a succinct answer. 8.12e+07. What is the difference between the highest and the lowest Aid flow (current US$) in Armenia?
Keep it short and to the point. 8.34e+07. What is the difference between the highest and the lowest Aid flow (current US$) in Ecuador?
Keep it short and to the point. 3.79e+07. What is the difference between the highest and the lowest Aid flow (current US$) of Honduras?
Give a very brief answer. 3.47e+07. What is the difference between the highest and the lowest Aid flow (current US$) of Lebanon?
Offer a very short reply. 1.58e+08. 